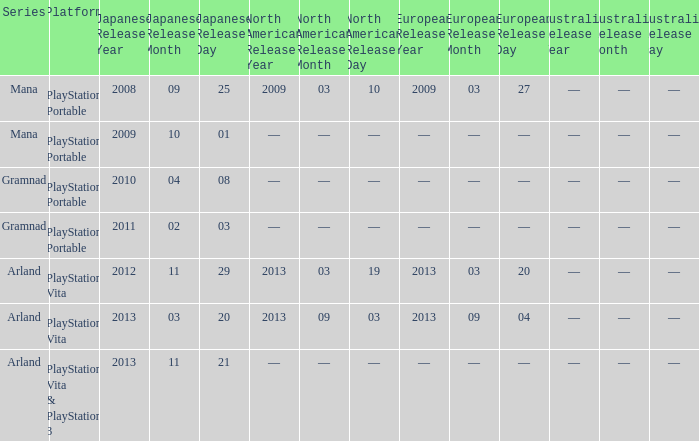What is the North American release date of the remake with a European release date on 2013-03-20? 2013-03-19. 